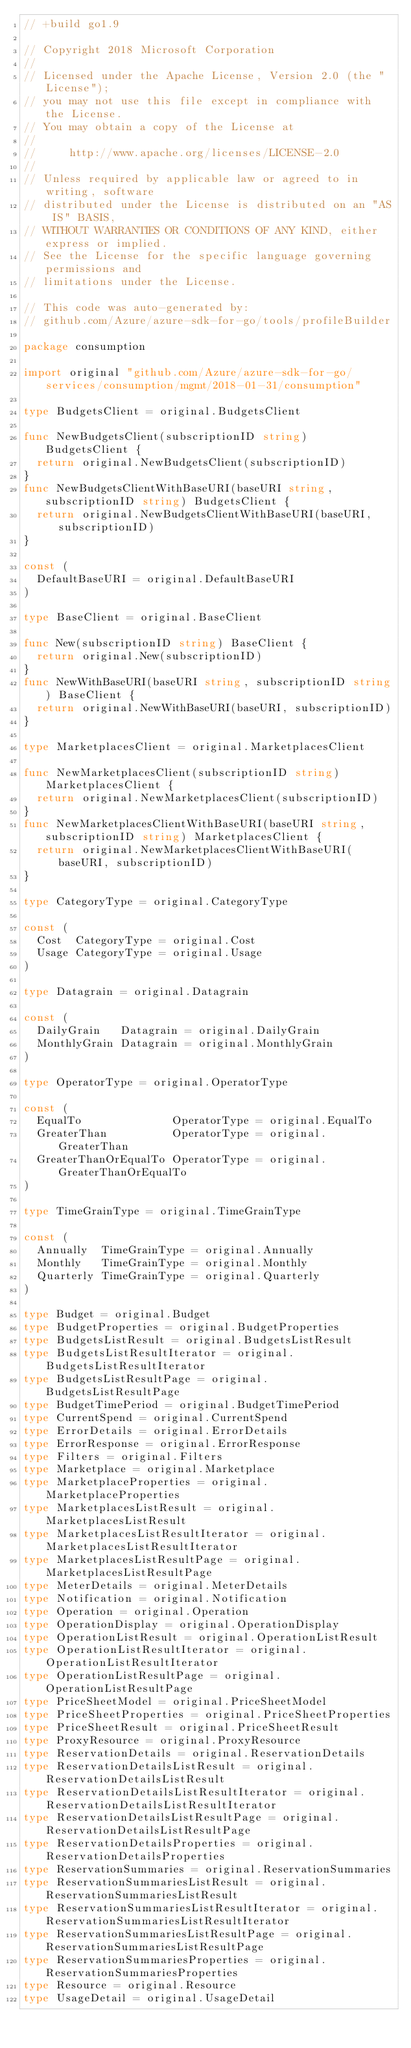Convert code to text. <code><loc_0><loc_0><loc_500><loc_500><_Go_>// +build go1.9

// Copyright 2018 Microsoft Corporation
//
// Licensed under the Apache License, Version 2.0 (the "License");
// you may not use this file except in compliance with the License.
// You may obtain a copy of the License at
//
//     http://www.apache.org/licenses/LICENSE-2.0
//
// Unless required by applicable law or agreed to in writing, software
// distributed under the License is distributed on an "AS IS" BASIS,
// WITHOUT WARRANTIES OR CONDITIONS OF ANY KIND, either express or implied.
// See the License for the specific language governing permissions and
// limitations under the License.

// This code was auto-generated by:
// github.com/Azure/azure-sdk-for-go/tools/profileBuilder

package consumption

import original "github.com/Azure/azure-sdk-for-go/services/consumption/mgmt/2018-01-31/consumption"

type BudgetsClient = original.BudgetsClient

func NewBudgetsClient(subscriptionID string) BudgetsClient {
	return original.NewBudgetsClient(subscriptionID)
}
func NewBudgetsClientWithBaseURI(baseURI string, subscriptionID string) BudgetsClient {
	return original.NewBudgetsClientWithBaseURI(baseURI, subscriptionID)
}

const (
	DefaultBaseURI = original.DefaultBaseURI
)

type BaseClient = original.BaseClient

func New(subscriptionID string) BaseClient {
	return original.New(subscriptionID)
}
func NewWithBaseURI(baseURI string, subscriptionID string) BaseClient {
	return original.NewWithBaseURI(baseURI, subscriptionID)
}

type MarketplacesClient = original.MarketplacesClient

func NewMarketplacesClient(subscriptionID string) MarketplacesClient {
	return original.NewMarketplacesClient(subscriptionID)
}
func NewMarketplacesClientWithBaseURI(baseURI string, subscriptionID string) MarketplacesClient {
	return original.NewMarketplacesClientWithBaseURI(baseURI, subscriptionID)
}

type CategoryType = original.CategoryType

const (
	Cost  CategoryType = original.Cost
	Usage CategoryType = original.Usage
)

type Datagrain = original.Datagrain

const (
	DailyGrain   Datagrain = original.DailyGrain
	MonthlyGrain Datagrain = original.MonthlyGrain
)

type OperatorType = original.OperatorType

const (
	EqualTo              OperatorType = original.EqualTo
	GreaterThan          OperatorType = original.GreaterThan
	GreaterThanOrEqualTo OperatorType = original.GreaterThanOrEqualTo
)

type TimeGrainType = original.TimeGrainType

const (
	Annually  TimeGrainType = original.Annually
	Monthly   TimeGrainType = original.Monthly
	Quarterly TimeGrainType = original.Quarterly
)

type Budget = original.Budget
type BudgetProperties = original.BudgetProperties
type BudgetsListResult = original.BudgetsListResult
type BudgetsListResultIterator = original.BudgetsListResultIterator
type BudgetsListResultPage = original.BudgetsListResultPage
type BudgetTimePeriod = original.BudgetTimePeriod
type CurrentSpend = original.CurrentSpend
type ErrorDetails = original.ErrorDetails
type ErrorResponse = original.ErrorResponse
type Filters = original.Filters
type Marketplace = original.Marketplace
type MarketplaceProperties = original.MarketplaceProperties
type MarketplacesListResult = original.MarketplacesListResult
type MarketplacesListResultIterator = original.MarketplacesListResultIterator
type MarketplacesListResultPage = original.MarketplacesListResultPage
type MeterDetails = original.MeterDetails
type Notification = original.Notification
type Operation = original.Operation
type OperationDisplay = original.OperationDisplay
type OperationListResult = original.OperationListResult
type OperationListResultIterator = original.OperationListResultIterator
type OperationListResultPage = original.OperationListResultPage
type PriceSheetModel = original.PriceSheetModel
type PriceSheetProperties = original.PriceSheetProperties
type PriceSheetResult = original.PriceSheetResult
type ProxyResource = original.ProxyResource
type ReservationDetails = original.ReservationDetails
type ReservationDetailsListResult = original.ReservationDetailsListResult
type ReservationDetailsListResultIterator = original.ReservationDetailsListResultIterator
type ReservationDetailsListResultPage = original.ReservationDetailsListResultPage
type ReservationDetailsProperties = original.ReservationDetailsProperties
type ReservationSummaries = original.ReservationSummaries
type ReservationSummariesListResult = original.ReservationSummariesListResult
type ReservationSummariesListResultIterator = original.ReservationSummariesListResultIterator
type ReservationSummariesListResultPage = original.ReservationSummariesListResultPage
type ReservationSummariesProperties = original.ReservationSummariesProperties
type Resource = original.Resource
type UsageDetail = original.UsageDetail</code> 